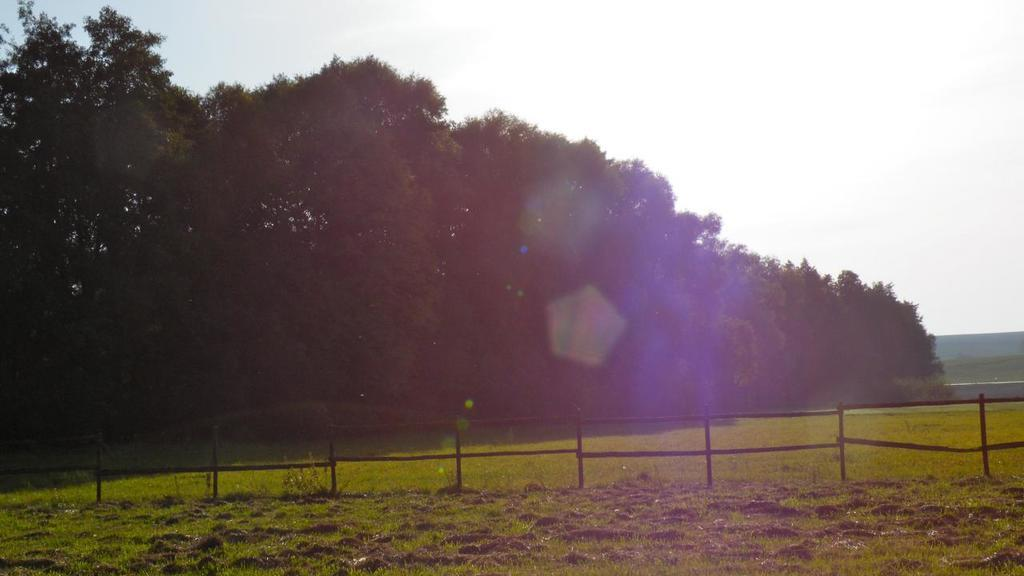What type of vegetation is in the foreground of the image? There is grass in the foreground of the image. What else can be seen in the foreground of the image? There is fencing in the foreground of the image. What type of vegetation is in the background of the image? There are trees in the background of the image. What is visible in the background of the image besides the trees? The sky is clear and visible in the background of the image. What type of pear is hanging from the fencing in the image? There is no pear present in the image; it features grass, fencing, trees, and a clear sky. What is causing the trees to sway in the image? There is no indication of movement or cause for the trees to sway in the image. 